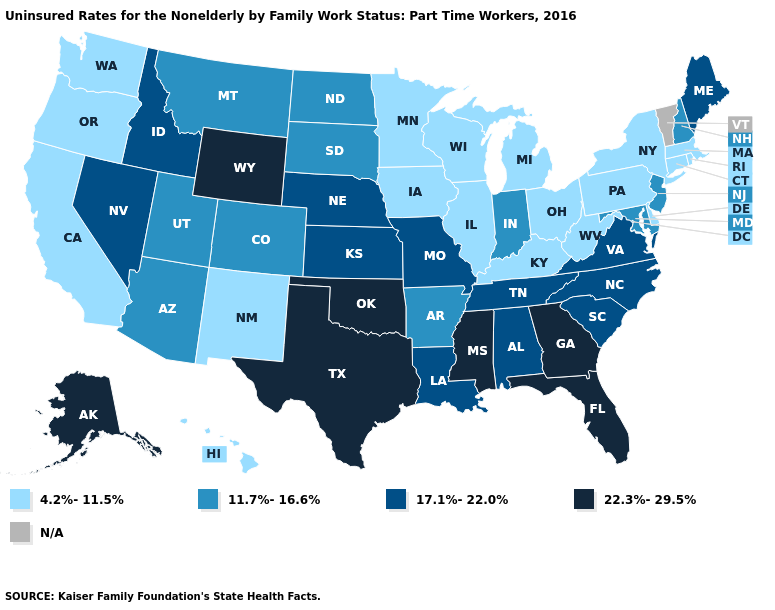What is the lowest value in the USA?
Answer briefly. 4.2%-11.5%. Name the states that have a value in the range 22.3%-29.5%?
Keep it brief. Alaska, Florida, Georgia, Mississippi, Oklahoma, Texas, Wyoming. Name the states that have a value in the range 22.3%-29.5%?
Give a very brief answer. Alaska, Florida, Georgia, Mississippi, Oklahoma, Texas, Wyoming. Does the map have missing data?
Concise answer only. Yes. Among the states that border Georgia , which have the highest value?
Give a very brief answer. Florida. Name the states that have a value in the range 22.3%-29.5%?
Concise answer only. Alaska, Florida, Georgia, Mississippi, Oklahoma, Texas, Wyoming. Which states have the lowest value in the USA?
Give a very brief answer. California, Connecticut, Delaware, Hawaii, Illinois, Iowa, Kentucky, Massachusetts, Michigan, Minnesota, New Mexico, New York, Ohio, Oregon, Pennsylvania, Rhode Island, Washington, West Virginia, Wisconsin. Name the states that have a value in the range 22.3%-29.5%?
Short answer required. Alaska, Florida, Georgia, Mississippi, Oklahoma, Texas, Wyoming. Which states have the lowest value in the USA?
Write a very short answer. California, Connecticut, Delaware, Hawaii, Illinois, Iowa, Kentucky, Massachusetts, Michigan, Minnesota, New Mexico, New York, Ohio, Oregon, Pennsylvania, Rhode Island, Washington, West Virginia, Wisconsin. Which states have the lowest value in the USA?
Keep it brief. California, Connecticut, Delaware, Hawaii, Illinois, Iowa, Kentucky, Massachusetts, Michigan, Minnesota, New Mexico, New York, Ohio, Oregon, Pennsylvania, Rhode Island, Washington, West Virginia, Wisconsin. Among the states that border New Mexico , does Utah have the lowest value?
Keep it brief. Yes. Name the states that have a value in the range 17.1%-22.0%?
Give a very brief answer. Alabama, Idaho, Kansas, Louisiana, Maine, Missouri, Nebraska, Nevada, North Carolina, South Carolina, Tennessee, Virginia. Name the states that have a value in the range 22.3%-29.5%?
Concise answer only. Alaska, Florida, Georgia, Mississippi, Oklahoma, Texas, Wyoming. 